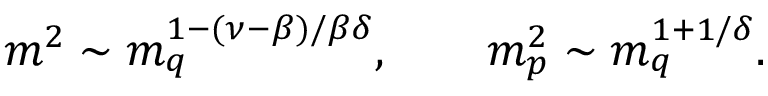Convert formula to latex. <formula><loc_0><loc_0><loc_500><loc_500>m ^ { 2 } \sim m _ { q } ^ { 1 - ( \nu - \beta ) / \beta \delta } , \quad m _ { p } ^ { 2 } \sim m _ { q } ^ { 1 + 1 / \delta } .</formula> 